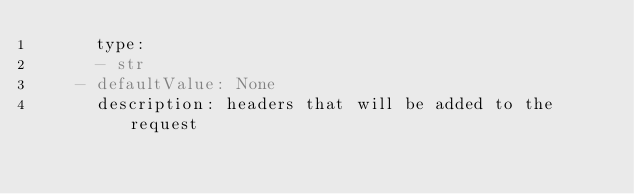Convert code to text. <code><loc_0><loc_0><loc_500><loc_500><_YAML_>      type:
      - str
    - defaultValue: None
      description: headers that will be added to the request</code> 